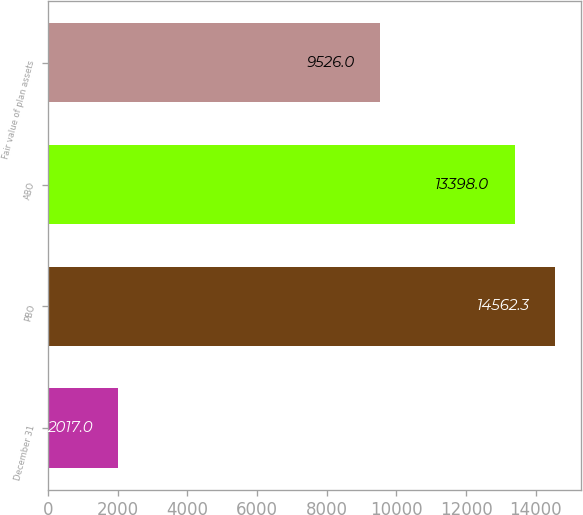Convert chart to OTSL. <chart><loc_0><loc_0><loc_500><loc_500><bar_chart><fcel>December 31<fcel>PBO<fcel>ABO<fcel>Fair value of plan assets<nl><fcel>2017<fcel>14562.3<fcel>13398<fcel>9526<nl></chart> 